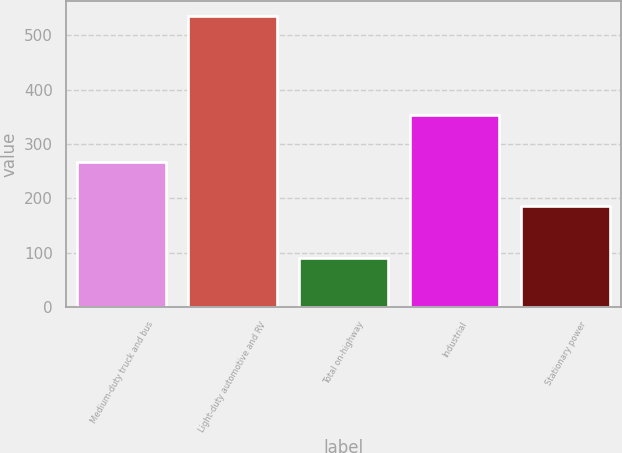Convert chart. <chart><loc_0><loc_0><loc_500><loc_500><bar_chart><fcel>Medium-duty truck and bus<fcel>Light-duty automotive and RV<fcel>Total on-highway<fcel>Industrial<fcel>Stationary power<nl><fcel>266<fcel>536<fcel>90<fcel>353<fcel>185<nl></chart> 